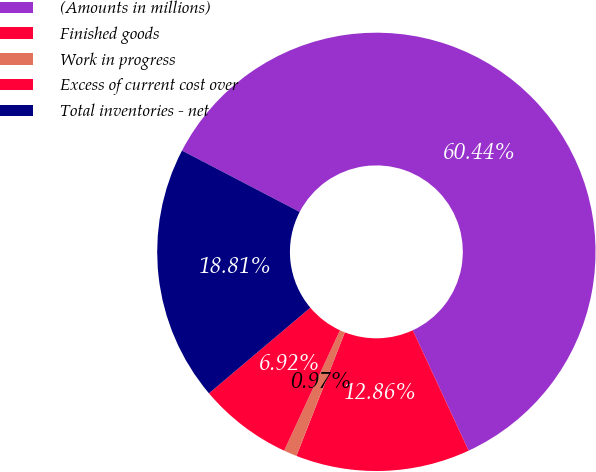Convert chart. <chart><loc_0><loc_0><loc_500><loc_500><pie_chart><fcel>(Amounts in millions)<fcel>Finished goods<fcel>Work in progress<fcel>Excess of current cost over<fcel>Total inventories - net<nl><fcel>60.44%<fcel>12.86%<fcel>0.97%<fcel>6.92%<fcel>18.81%<nl></chart> 